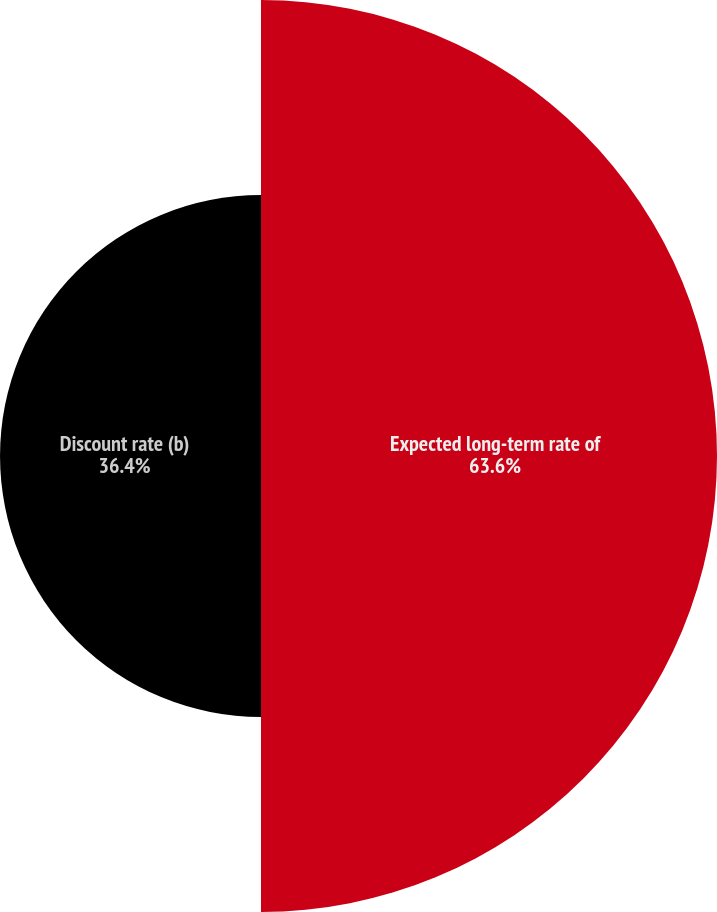Convert chart to OTSL. <chart><loc_0><loc_0><loc_500><loc_500><pie_chart><fcel>Expected long-term rate of<fcel>Discount rate (b)<nl><fcel>63.6%<fcel>36.4%<nl></chart> 